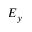Convert formula to latex. <formula><loc_0><loc_0><loc_500><loc_500>E _ { y }</formula> 